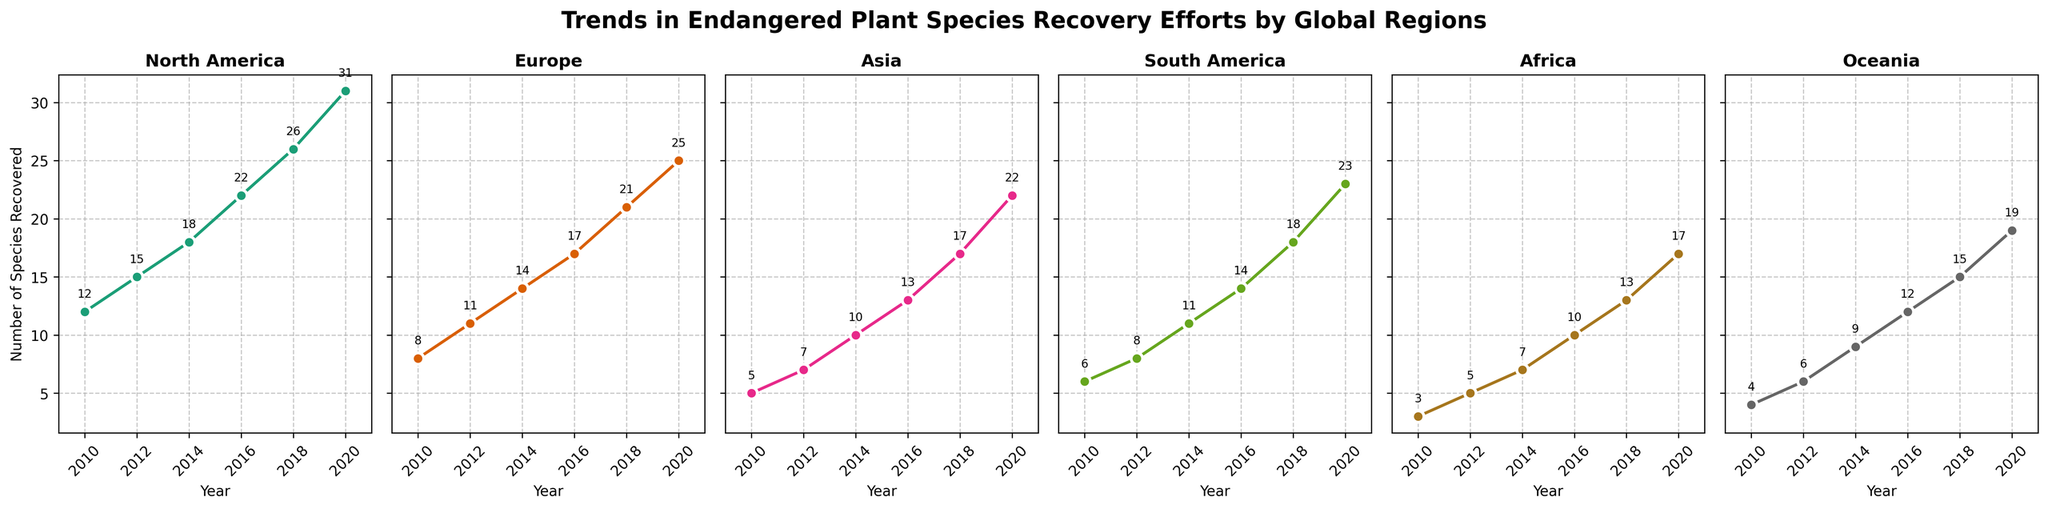What trend is shown in the number of recovered species in North America from 2010 to 2020? Looking at the subplot for North America, the number of recovered species increases consistently from 12 in 2010 to 31 in 2020. This shows a positive upward trend.
Answer: Increasing Which region shows the highest number of species recovered in 2020? Reviewing each subplot and noting the values for 2020, Oceania shows 19, Africa shows 17, South America shows 23, Asia shows 22, Europe shows 25, and North America shows 31. Hence, North America has the highest number of species recovered in 2020.
Answer: North America Compare the number of species recovered in Europe and Asia in 2016. Which region has a higher number? The subplot for Europe shows 17 species recovered in 2016, while the subplot for Asia shows 13 species in the same year. Therefore, Europe has a higher number of species recovered in 2016.
Answer: Europe By what factor did the number of species recovered in Africa increase from 2010 to 2020? In the Africa subplot, the species recovered in 2010 were 3, and in 2020, it rose to 17. The increase factor is computed as 17 divided by 3, which equals approximately 5.67.
Answer: 5.67 What is the average number of species recovered in Oceania over the years shown? Calculating the average involves summing the numbers for 2010-2020 (4, 6, 9, 12, 15, 19) which equals 65, and then dividing by the number of years (6). Thus, 65 divided by 6 equals approximately 10.83.
Answer: 10.83 Which regions exhibit a faster increase in species recovery rate: Africa or South America? Evaluating the slopes shown in the subplots: Africa shows an increase from 3 in 2010 to 17 in 2020, while South America shows an increase from 6 in 2010 to 23 in 2020. The slopes are 14 (Africa, 17-3) and 17 (South America, 23-6) over 10 years, indicating South America has a faster increase.
Answer: South America How many more species were recovered in 2020 compared to 2010 in Asia? According to the subplot for Asia, the species recovered in 2020 were 22, while in 2010 it was 5. The difference is calculated as 22 minus 5, which is 17.
Answer: 17 What is the cumulative number of species recovered across all regions in 2016? Summing the number of recovered species in 2016 from all subplots: North America (22) + Europe (17) + Asia (13) + South America (14) + Africa (10) + Oceania (12) equals 88.
Answer: 88 Which region had the least species recovered in 2018, and how many species were recovered? Reviewing each subplot for 2018: North America (26), Europe (21), Asia (17), South America (18), Africa (13), Oceania (15). Therefore, Africa had the least, with 13 species recovered.
Answer: Africa with 13 Is the recovery pace in Europe faster in the first 4 years (2010-2014) or the last 6 years (2014-2020)? First, calculate the increase in species for both periods. From 2010 to 2014: 14 - 8 = 6; and from 2014 to 2020: 25 - 14 = 11. Then, calculate the respective rates: 6 species/4 years = 1.5 species/year, 11 species/6 years = 1.83 species/year. Therefore, the recovery pace was faster in the last 6 years.
Answer: Last 6 years 